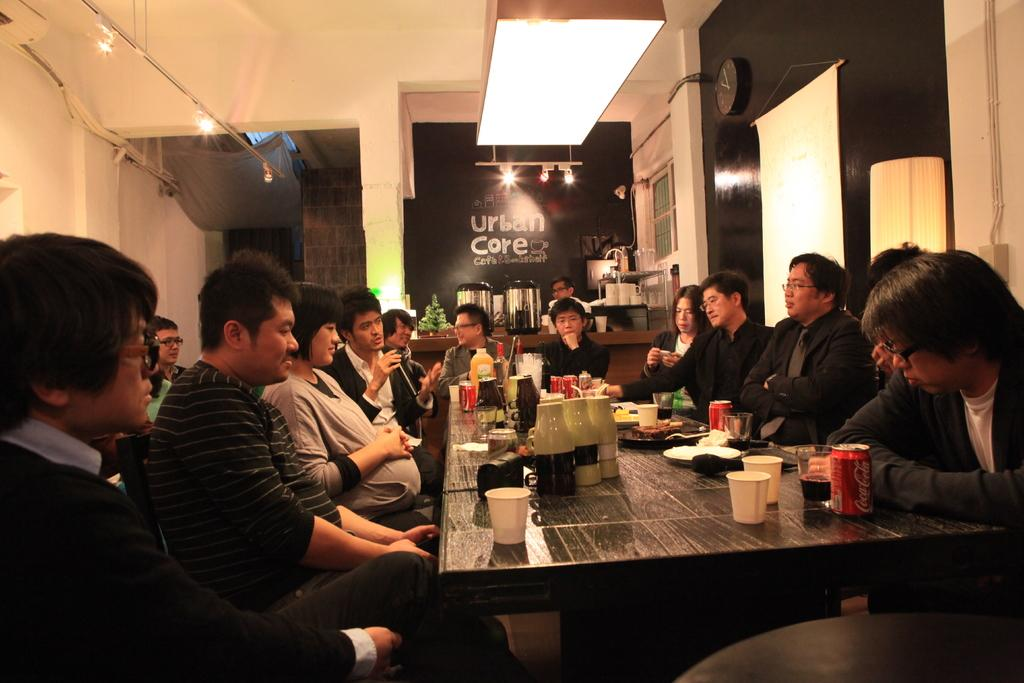<image>
Describe the image concisely. A large gathering of people having dinner and drinks at a restaurant called Urban Core. 